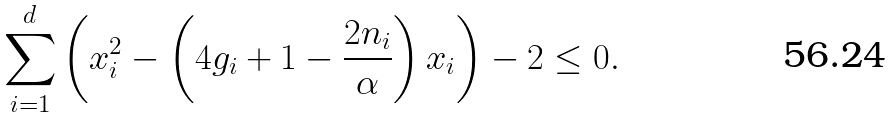Convert formula to latex. <formula><loc_0><loc_0><loc_500><loc_500>\sum _ { i = 1 } ^ { d } \left ( x _ { i } ^ { 2 } - \left ( 4 g _ { i } + 1 - \frac { 2 n _ { i } } { \alpha } \right ) x _ { i } \right ) - 2 \leq 0 .</formula> 